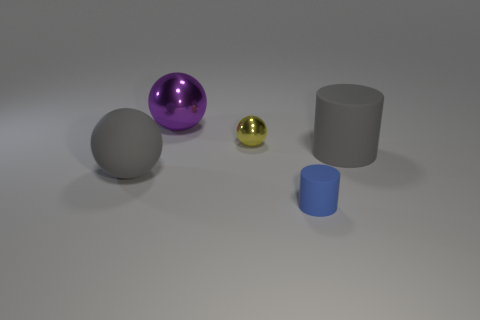Subtract all large spheres. How many spheres are left? 1 Subtract 1 spheres. How many spheres are left? 2 Add 5 gray rubber balls. How many objects exist? 10 Subtract all cylinders. How many objects are left? 3 Subtract 0 brown cubes. How many objects are left? 5 Subtract all big metallic blocks. Subtract all purple metal spheres. How many objects are left? 4 Add 1 small shiny balls. How many small shiny balls are left? 2 Add 4 big purple rubber spheres. How many big purple rubber spheres exist? 4 